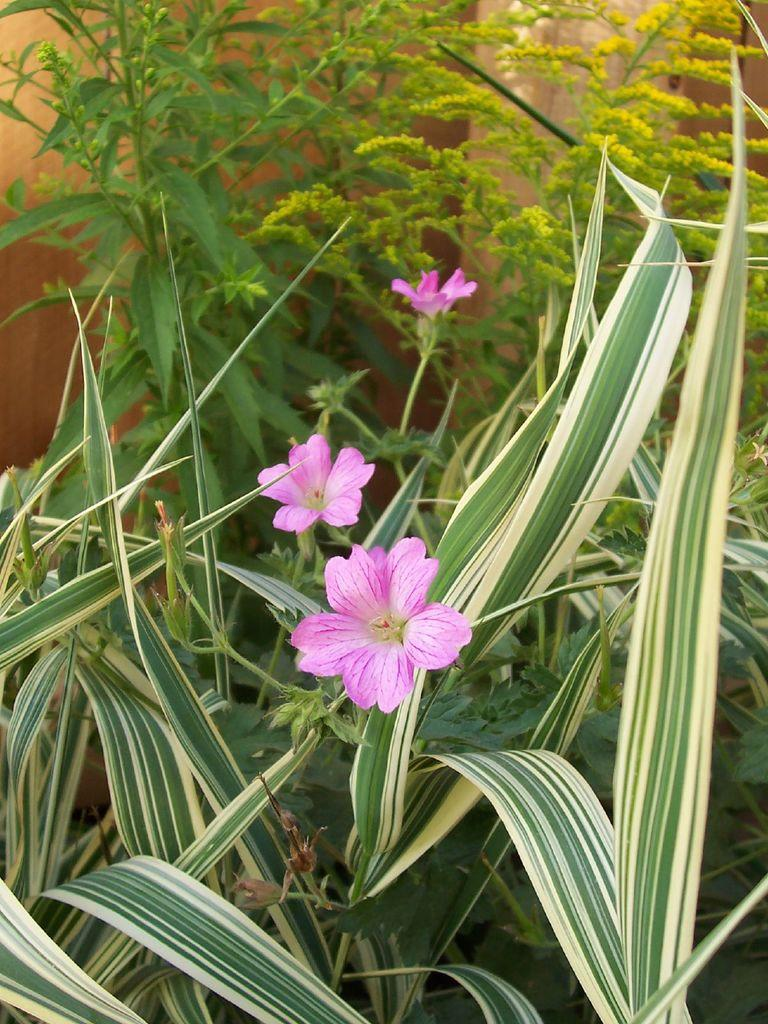What type of plants can be seen in the image? There are flowering plants in the image. What color are the leaves of the plants? There are green leaves in the image. What is visible in the background of the image? There is a wall in the background of the image. How many cakes are being held by the fairies in the image? There are no cakes or fairies present in the image. What type of fruit is being used to decorate the oranges in the image? There are no oranges or fruit decorations present in the image. 